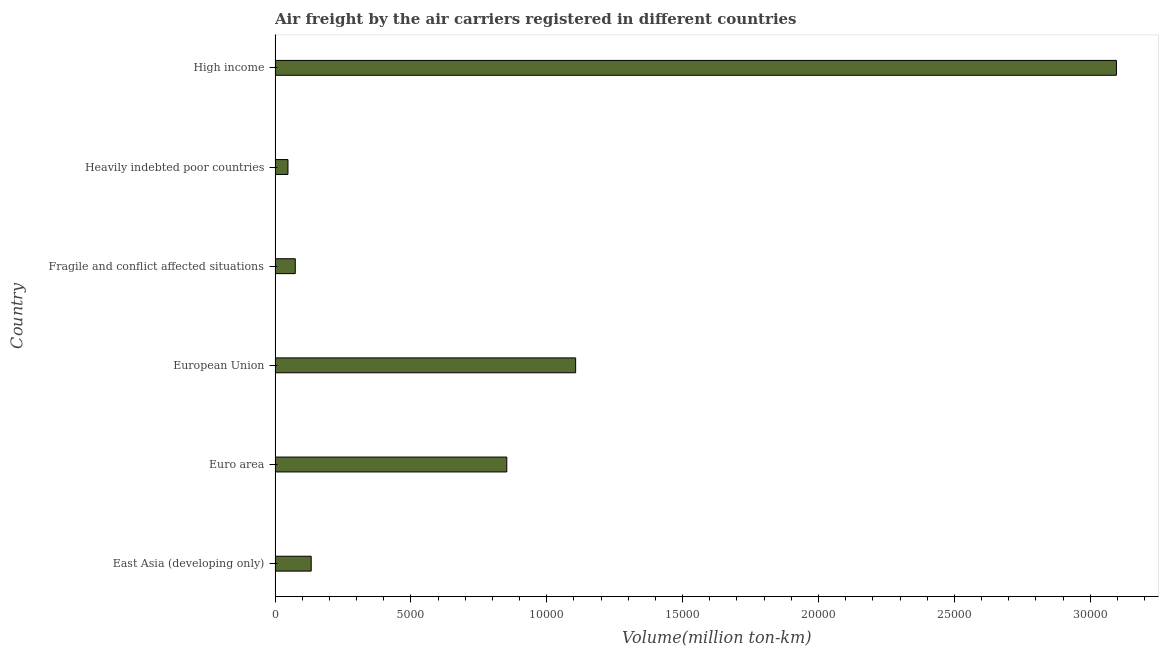Does the graph contain grids?
Make the answer very short. No. What is the title of the graph?
Your answer should be very brief. Air freight by the air carriers registered in different countries. What is the label or title of the X-axis?
Your answer should be compact. Volume(million ton-km). What is the label or title of the Y-axis?
Make the answer very short. Country. What is the air freight in European Union?
Provide a succinct answer. 1.11e+04. Across all countries, what is the maximum air freight?
Your response must be concise. 3.10e+04. Across all countries, what is the minimum air freight?
Offer a very short reply. 473.6. In which country was the air freight minimum?
Offer a terse response. Heavily indebted poor countries. What is the sum of the air freight?
Give a very brief answer. 5.31e+04. What is the difference between the air freight in Euro area and High income?
Provide a succinct answer. -2.24e+04. What is the average air freight per country?
Your answer should be compact. 8850.05. What is the median air freight?
Make the answer very short. 4928.8. What is the ratio of the air freight in Euro area to that in High income?
Your answer should be compact. 0.28. Is the air freight in East Asia (developing only) less than that in Heavily indebted poor countries?
Provide a succinct answer. No. Is the difference between the air freight in Euro area and European Union greater than the difference between any two countries?
Provide a succinct answer. No. What is the difference between the highest and the second highest air freight?
Make the answer very short. 1.99e+04. Is the sum of the air freight in Euro area and High income greater than the maximum air freight across all countries?
Provide a short and direct response. Yes. What is the difference between the highest and the lowest air freight?
Ensure brevity in your answer.  3.05e+04. In how many countries, is the air freight greater than the average air freight taken over all countries?
Your response must be concise. 2. How many bars are there?
Offer a very short reply. 6. How many countries are there in the graph?
Your answer should be compact. 6. Are the values on the major ticks of X-axis written in scientific E-notation?
Your response must be concise. No. What is the Volume(million ton-km) in East Asia (developing only)?
Your answer should be very brief. 1329.6. What is the Volume(million ton-km) in Euro area?
Offer a terse response. 8528. What is the Volume(million ton-km) in European Union?
Make the answer very short. 1.11e+04. What is the Volume(million ton-km) of Fragile and conflict affected situations?
Make the answer very short. 742.9. What is the Volume(million ton-km) in Heavily indebted poor countries?
Your answer should be compact. 473.6. What is the Volume(million ton-km) in High income?
Your answer should be compact. 3.10e+04. What is the difference between the Volume(million ton-km) in East Asia (developing only) and Euro area?
Offer a very short reply. -7198.4. What is the difference between the Volume(million ton-km) in East Asia (developing only) and European Union?
Your answer should be compact. -9732. What is the difference between the Volume(million ton-km) in East Asia (developing only) and Fragile and conflict affected situations?
Your response must be concise. 586.7. What is the difference between the Volume(million ton-km) in East Asia (developing only) and Heavily indebted poor countries?
Ensure brevity in your answer.  856. What is the difference between the Volume(million ton-km) in East Asia (developing only) and High income?
Your answer should be compact. -2.96e+04. What is the difference between the Volume(million ton-km) in Euro area and European Union?
Keep it short and to the point. -2533.6. What is the difference between the Volume(million ton-km) in Euro area and Fragile and conflict affected situations?
Make the answer very short. 7785.1. What is the difference between the Volume(million ton-km) in Euro area and Heavily indebted poor countries?
Provide a succinct answer. 8054.4. What is the difference between the Volume(million ton-km) in Euro area and High income?
Offer a very short reply. -2.24e+04. What is the difference between the Volume(million ton-km) in European Union and Fragile and conflict affected situations?
Keep it short and to the point. 1.03e+04. What is the difference between the Volume(million ton-km) in European Union and Heavily indebted poor countries?
Your response must be concise. 1.06e+04. What is the difference between the Volume(million ton-km) in European Union and High income?
Ensure brevity in your answer.  -1.99e+04. What is the difference between the Volume(million ton-km) in Fragile and conflict affected situations and Heavily indebted poor countries?
Keep it short and to the point. 269.3. What is the difference between the Volume(million ton-km) in Fragile and conflict affected situations and High income?
Ensure brevity in your answer.  -3.02e+04. What is the difference between the Volume(million ton-km) in Heavily indebted poor countries and High income?
Your answer should be very brief. -3.05e+04. What is the ratio of the Volume(million ton-km) in East Asia (developing only) to that in Euro area?
Provide a succinct answer. 0.16. What is the ratio of the Volume(million ton-km) in East Asia (developing only) to that in European Union?
Provide a succinct answer. 0.12. What is the ratio of the Volume(million ton-km) in East Asia (developing only) to that in Fragile and conflict affected situations?
Your response must be concise. 1.79. What is the ratio of the Volume(million ton-km) in East Asia (developing only) to that in Heavily indebted poor countries?
Keep it short and to the point. 2.81. What is the ratio of the Volume(million ton-km) in East Asia (developing only) to that in High income?
Your answer should be very brief. 0.04. What is the ratio of the Volume(million ton-km) in Euro area to that in European Union?
Ensure brevity in your answer.  0.77. What is the ratio of the Volume(million ton-km) in Euro area to that in Fragile and conflict affected situations?
Give a very brief answer. 11.48. What is the ratio of the Volume(million ton-km) in Euro area to that in Heavily indebted poor countries?
Ensure brevity in your answer.  18.01. What is the ratio of the Volume(million ton-km) in Euro area to that in High income?
Your answer should be very brief. 0.28. What is the ratio of the Volume(million ton-km) in European Union to that in Fragile and conflict affected situations?
Give a very brief answer. 14.89. What is the ratio of the Volume(million ton-km) in European Union to that in Heavily indebted poor countries?
Offer a very short reply. 23.36. What is the ratio of the Volume(million ton-km) in European Union to that in High income?
Give a very brief answer. 0.36. What is the ratio of the Volume(million ton-km) in Fragile and conflict affected situations to that in Heavily indebted poor countries?
Keep it short and to the point. 1.57. What is the ratio of the Volume(million ton-km) in Fragile and conflict affected situations to that in High income?
Your response must be concise. 0.02. What is the ratio of the Volume(million ton-km) in Heavily indebted poor countries to that in High income?
Give a very brief answer. 0.01. 